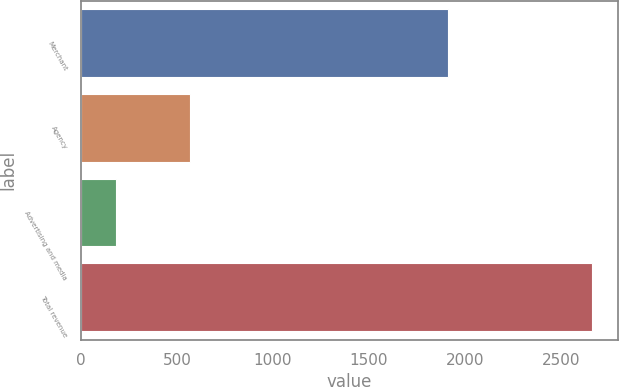Convert chart to OTSL. <chart><loc_0><loc_0><loc_500><loc_500><bar_chart><fcel>Merchant<fcel>Agency<fcel>Advertising and media<fcel>Total revenue<nl><fcel>1915<fcel>567<fcel>183<fcel>2665<nl></chart> 